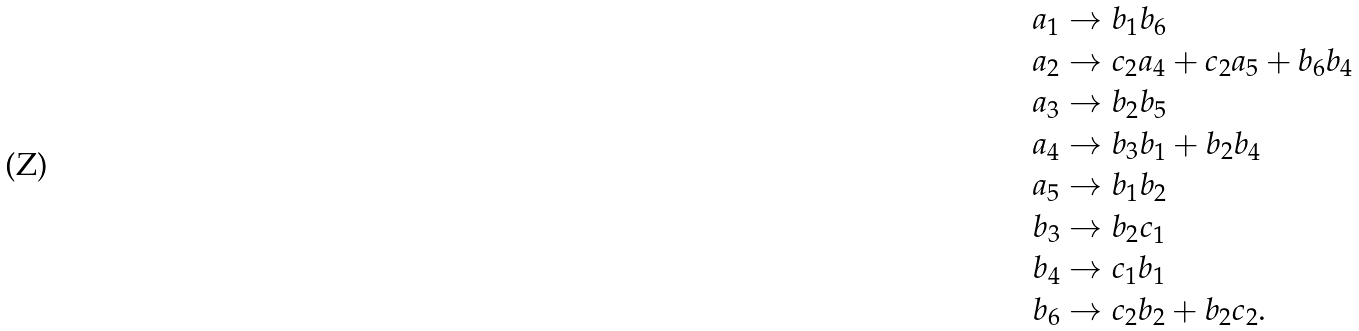<formula> <loc_0><loc_0><loc_500><loc_500>a _ { 1 } & \rightarrow b _ { 1 } b _ { 6 } \\ a _ { 2 } & \rightarrow c _ { 2 } a _ { 4 } + c _ { 2 } a _ { 5 } + b _ { 6 } b _ { 4 } \\ a _ { 3 } & \rightarrow b _ { 2 } b _ { 5 } \\ a _ { 4 } & \rightarrow b _ { 3 } b _ { 1 } + b _ { 2 } b _ { 4 } \\ a _ { 5 } & \rightarrow b _ { 1 } b _ { 2 } \\ b _ { 3 } & \rightarrow b _ { 2 } c _ { 1 } \\ b _ { 4 } & \rightarrow c _ { 1 } b _ { 1 } \\ b _ { 6 } & \rightarrow c _ { 2 } b _ { 2 } + b _ { 2 } c _ { 2 } .</formula> 